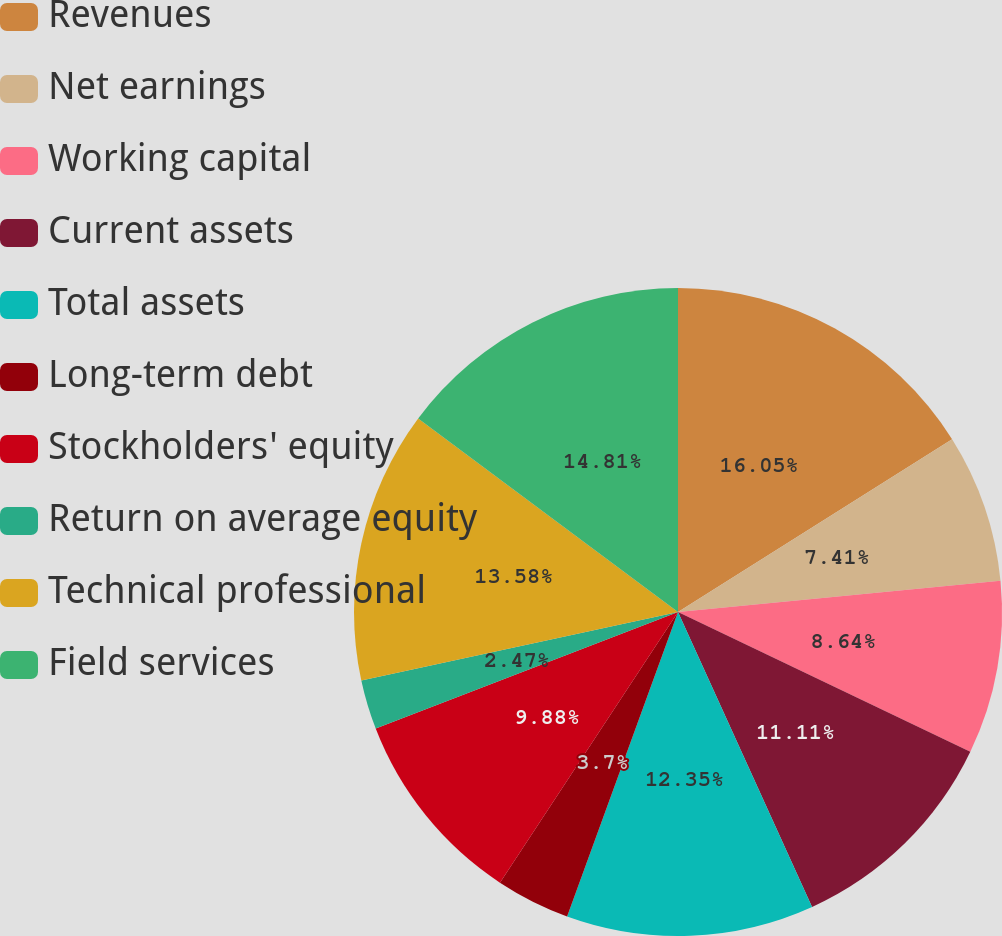Convert chart. <chart><loc_0><loc_0><loc_500><loc_500><pie_chart><fcel>Revenues<fcel>Net earnings<fcel>Working capital<fcel>Current assets<fcel>Total assets<fcel>Long-term debt<fcel>Stockholders' equity<fcel>Return on average equity<fcel>Technical professional<fcel>Field services<nl><fcel>16.05%<fcel>7.41%<fcel>8.64%<fcel>11.11%<fcel>12.35%<fcel>3.7%<fcel>9.88%<fcel>2.47%<fcel>13.58%<fcel>14.81%<nl></chart> 